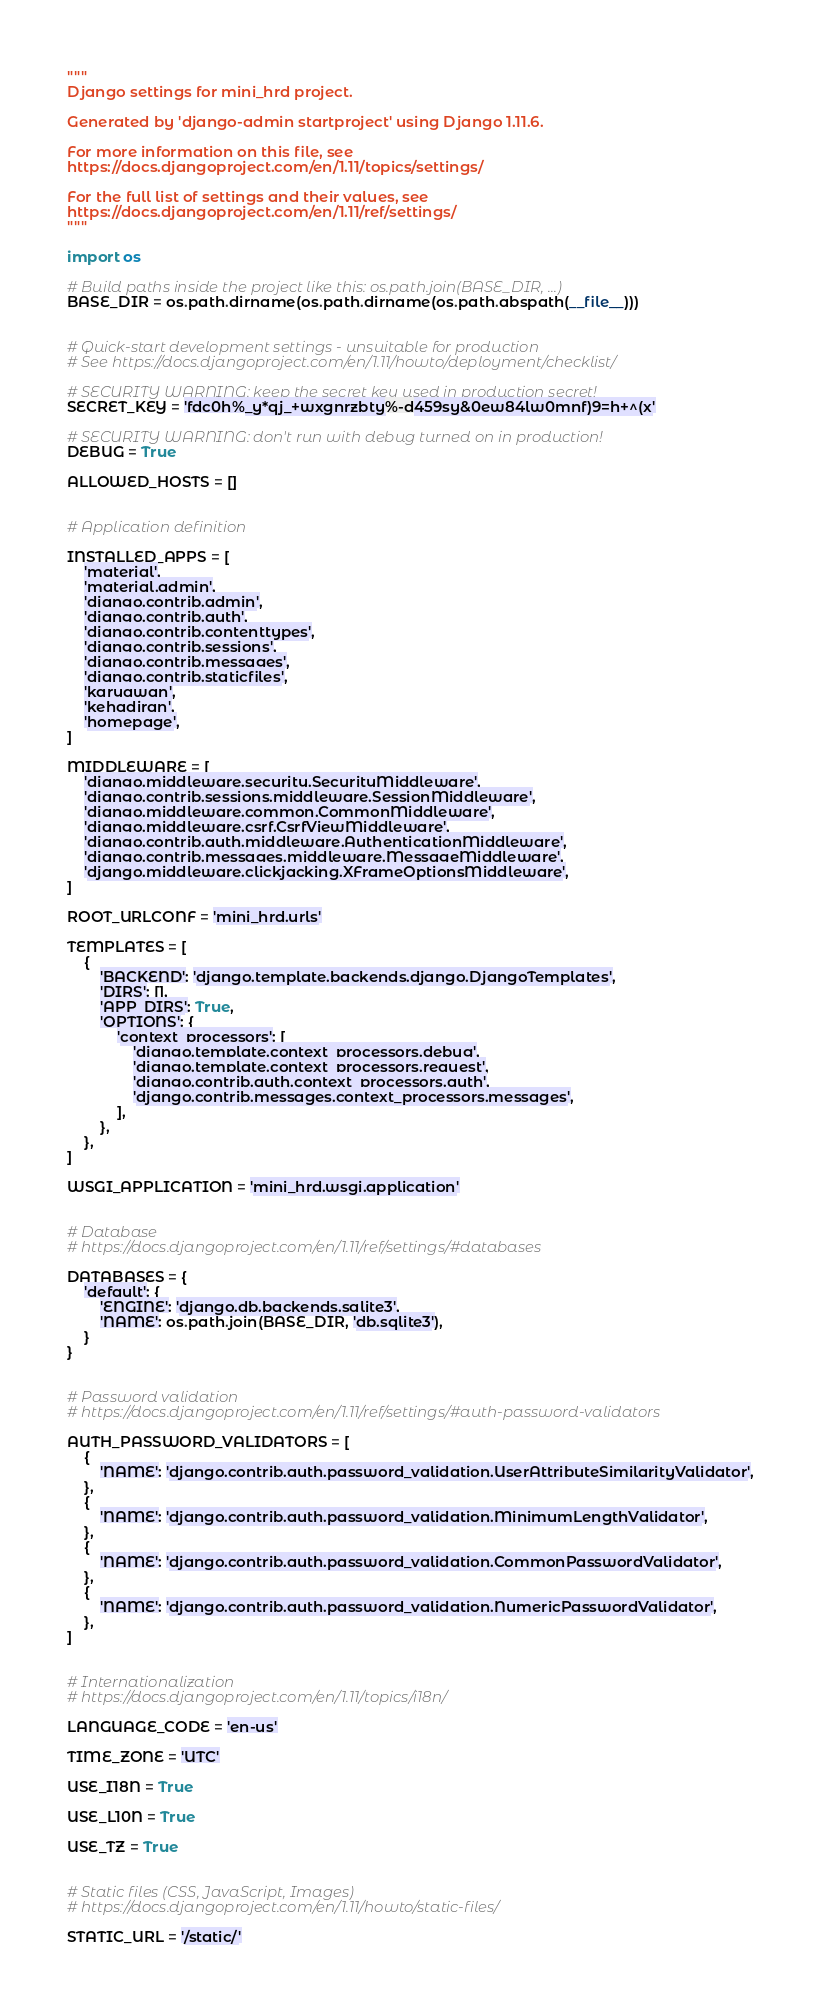Convert code to text. <code><loc_0><loc_0><loc_500><loc_500><_Python_>"""
Django settings for mini_hrd project.

Generated by 'django-admin startproject' using Django 1.11.6.

For more information on this file, see
https://docs.djangoproject.com/en/1.11/topics/settings/

For the full list of settings and their values, see
https://docs.djangoproject.com/en/1.11/ref/settings/
"""

import os

# Build paths inside the project like this: os.path.join(BASE_DIR, ...)
BASE_DIR = os.path.dirname(os.path.dirname(os.path.abspath(__file__)))


# Quick-start development settings - unsuitable for production
# See https://docs.djangoproject.com/en/1.11/howto/deployment/checklist/

# SECURITY WARNING: keep the secret key used in production secret!
SECRET_KEY = 'fdc0h%_y*qj_+wxgnrzbty%-d459sy&0ew84lw0mnf)9=h+^(x'

# SECURITY WARNING: don't run with debug turned on in production!
DEBUG = True

ALLOWED_HOSTS = []


# Application definition

INSTALLED_APPS = [
    'material',
    'material.admin',
    'django.contrib.admin',
    'django.contrib.auth',
    'django.contrib.contenttypes',
    'django.contrib.sessions',
    'django.contrib.messages',
    'django.contrib.staticfiles',
    'karyawan',
    'kehadiran',
    'homepage',
]

MIDDLEWARE = [
    'django.middleware.security.SecurityMiddleware',
    'django.contrib.sessions.middleware.SessionMiddleware',
    'django.middleware.common.CommonMiddleware',
    'django.middleware.csrf.CsrfViewMiddleware',
    'django.contrib.auth.middleware.AuthenticationMiddleware',
    'django.contrib.messages.middleware.MessageMiddleware',
    'django.middleware.clickjacking.XFrameOptionsMiddleware',
]

ROOT_URLCONF = 'mini_hrd.urls'

TEMPLATES = [
    {
        'BACKEND': 'django.template.backends.django.DjangoTemplates',
        'DIRS': [],
        'APP_DIRS': True,
        'OPTIONS': {
            'context_processors': [
                'django.template.context_processors.debug',
                'django.template.context_processors.request',
                'django.contrib.auth.context_processors.auth',
                'django.contrib.messages.context_processors.messages',
            ],
        },
    },
]

WSGI_APPLICATION = 'mini_hrd.wsgi.application'


# Database
# https://docs.djangoproject.com/en/1.11/ref/settings/#databases

DATABASES = {
    'default': {
        'ENGINE': 'django.db.backends.sqlite3',
        'NAME': os.path.join(BASE_DIR, 'db.sqlite3'),
    }
}


# Password validation
# https://docs.djangoproject.com/en/1.11/ref/settings/#auth-password-validators

AUTH_PASSWORD_VALIDATORS = [
    {
        'NAME': 'django.contrib.auth.password_validation.UserAttributeSimilarityValidator',
    },
    {
        'NAME': 'django.contrib.auth.password_validation.MinimumLengthValidator',
    },
    {
        'NAME': 'django.contrib.auth.password_validation.CommonPasswordValidator',
    },
    {
        'NAME': 'django.contrib.auth.password_validation.NumericPasswordValidator',
    },
]


# Internationalization
# https://docs.djangoproject.com/en/1.11/topics/i18n/

LANGUAGE_CODE = 'en-us'

TIME_ZONE = 'UTC'

USE_I18N = True

USE_L10N = True

USE_TZ = True


# Static files (CSS, JavaScript, Images)
# https://docs.djangoproject.com/en/1.11/howto/static-files/

STATIC_URL = '/static/'
</code> 